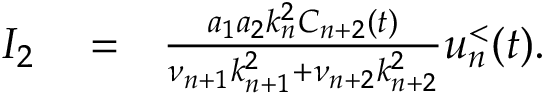Convert formula to latex. <formula><loc_0><loc_0><loc_500><loc_500>\begin{array} { r l r } { I _ { 2 } } & = } & { \frac { a _ { 1 } a _ { 2 } k _ { n } ^ { 2 } C _ { n + 2 } ( t ) } { \nu _ { n + 1 } k _ { n + 1 } ^ { 2 } + \nu _ { n + 2 } k _ { n + 2 } ^ { 2 } } u _ { n } ^ { < } ( t ) . } \end{array}</formula> 